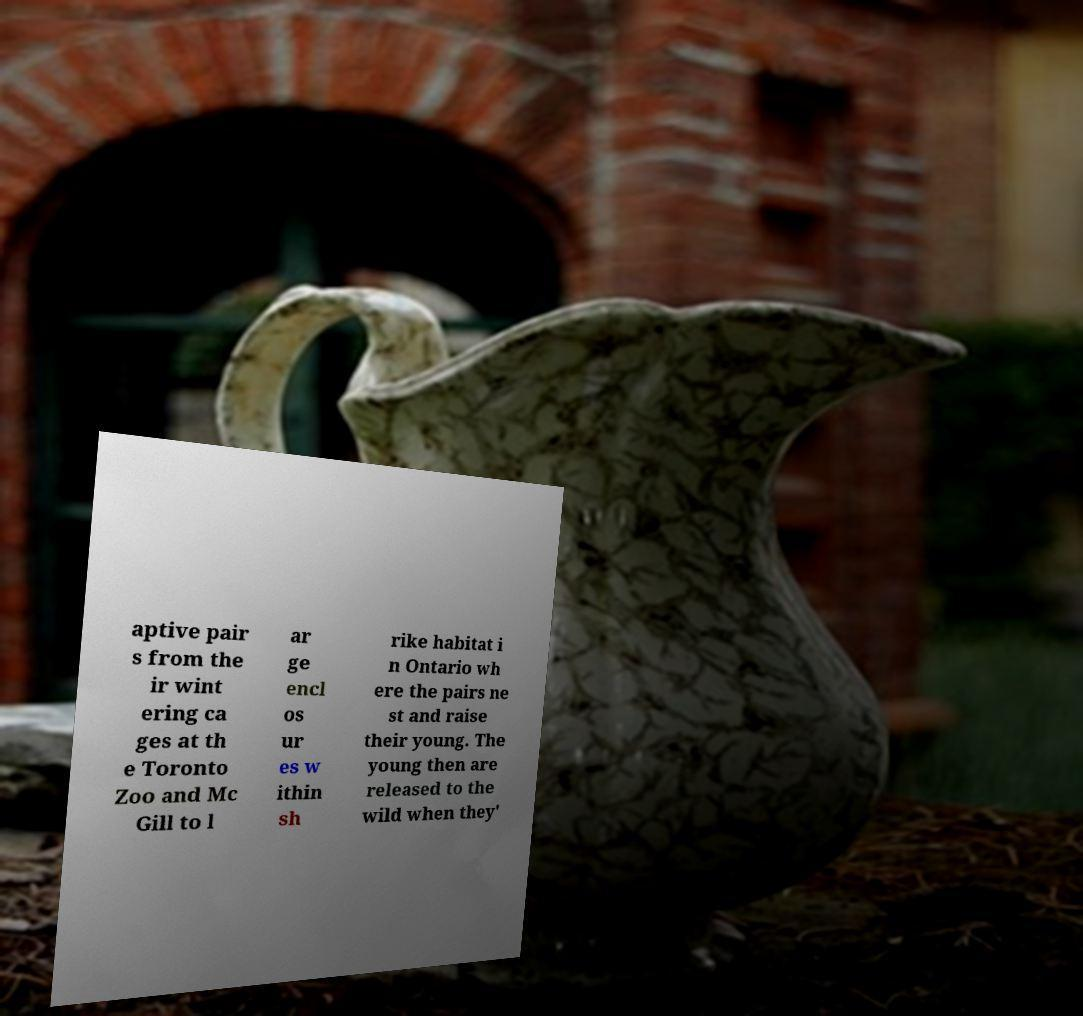There's text embedded in this image that I need extracted. Can you transcribe it verbatim? aptive pair s from the ir wint ering ca ges at th e Toronto Zoo and Mc Gill to l ar ge encl os ur es w ithin sh rike habitat i n Ontario wh ere the pairs ne st and raise their young. The young then are released to the wild when they' 